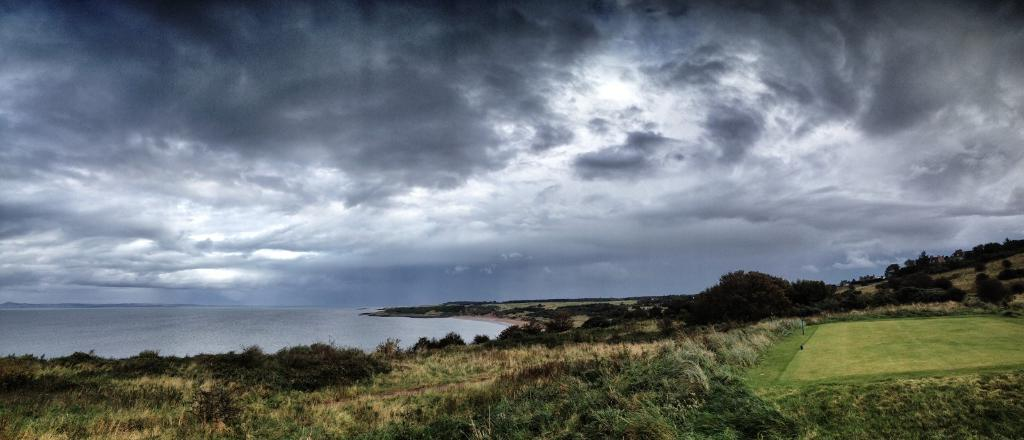What is located in the center of the image? There are trees and grass in the center of the image. What can be seen on the ground in the center of the image? The ground is visible in the center of the image. What is present on the left side of the image? There is water on the left side of the image. What is visible in the sky at the top of the image? Clouds are present in the sky at the top of the image. What type of letters can be seen floating in the water on the left side of the image? There are no letters present in the image; it features trees, grass, ground, water, and clouds. How does the sponge absorb water in the image? There is no sponge present in the image. 